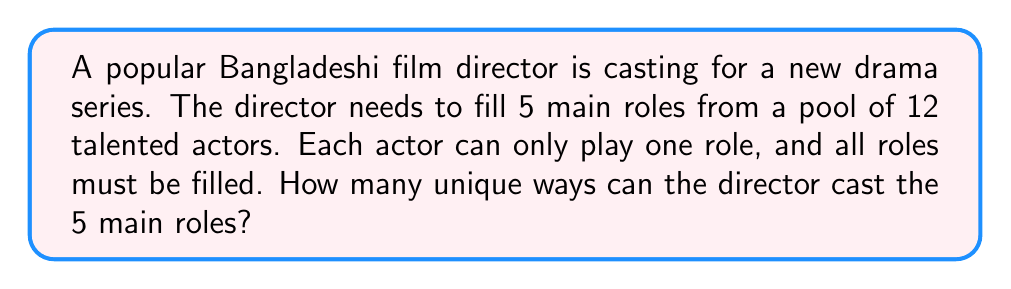Solve this math problem. Let's approach this step-by-step:

1) This is a permutation problem because the order matters (each role is distinct) and we're selecting actors without replacement (each actor can only play one role).

2) We're choosing 5 actors out of 12, where the order matters. This is denoted as $P(12,5)$ or $_{12}P_5$.

3) The formula for this permutation is:

   $$P(n,r) = \frac{n!}{(n-r)!}$$

   Where $n$ is the total number of items to choose from, and $r$ is the number of items being chosen.

4) In this case, $n = 12$ (total actors) and $r = 5$ (roles to be filled).

5) Plugging these numbers into our formula:

   $$P(12,5) = \frac{12!}{(12-5)!} = \frac{12!}{7!}$$

6) Expanding this:
   
   $$\frac{12 \times 11 \times 10 \times 9 \times 8 \times 7!}{7!}$$

7) The $7!$ cancels out in the numerator and denominator:

   $$12 \times 11 \times 10 \times 9 \times 8 = 95,040$$

Therefore, there are 95,040 unique ways to cast the 5 main roles from the 12 available actors.
Answer: 95,040 